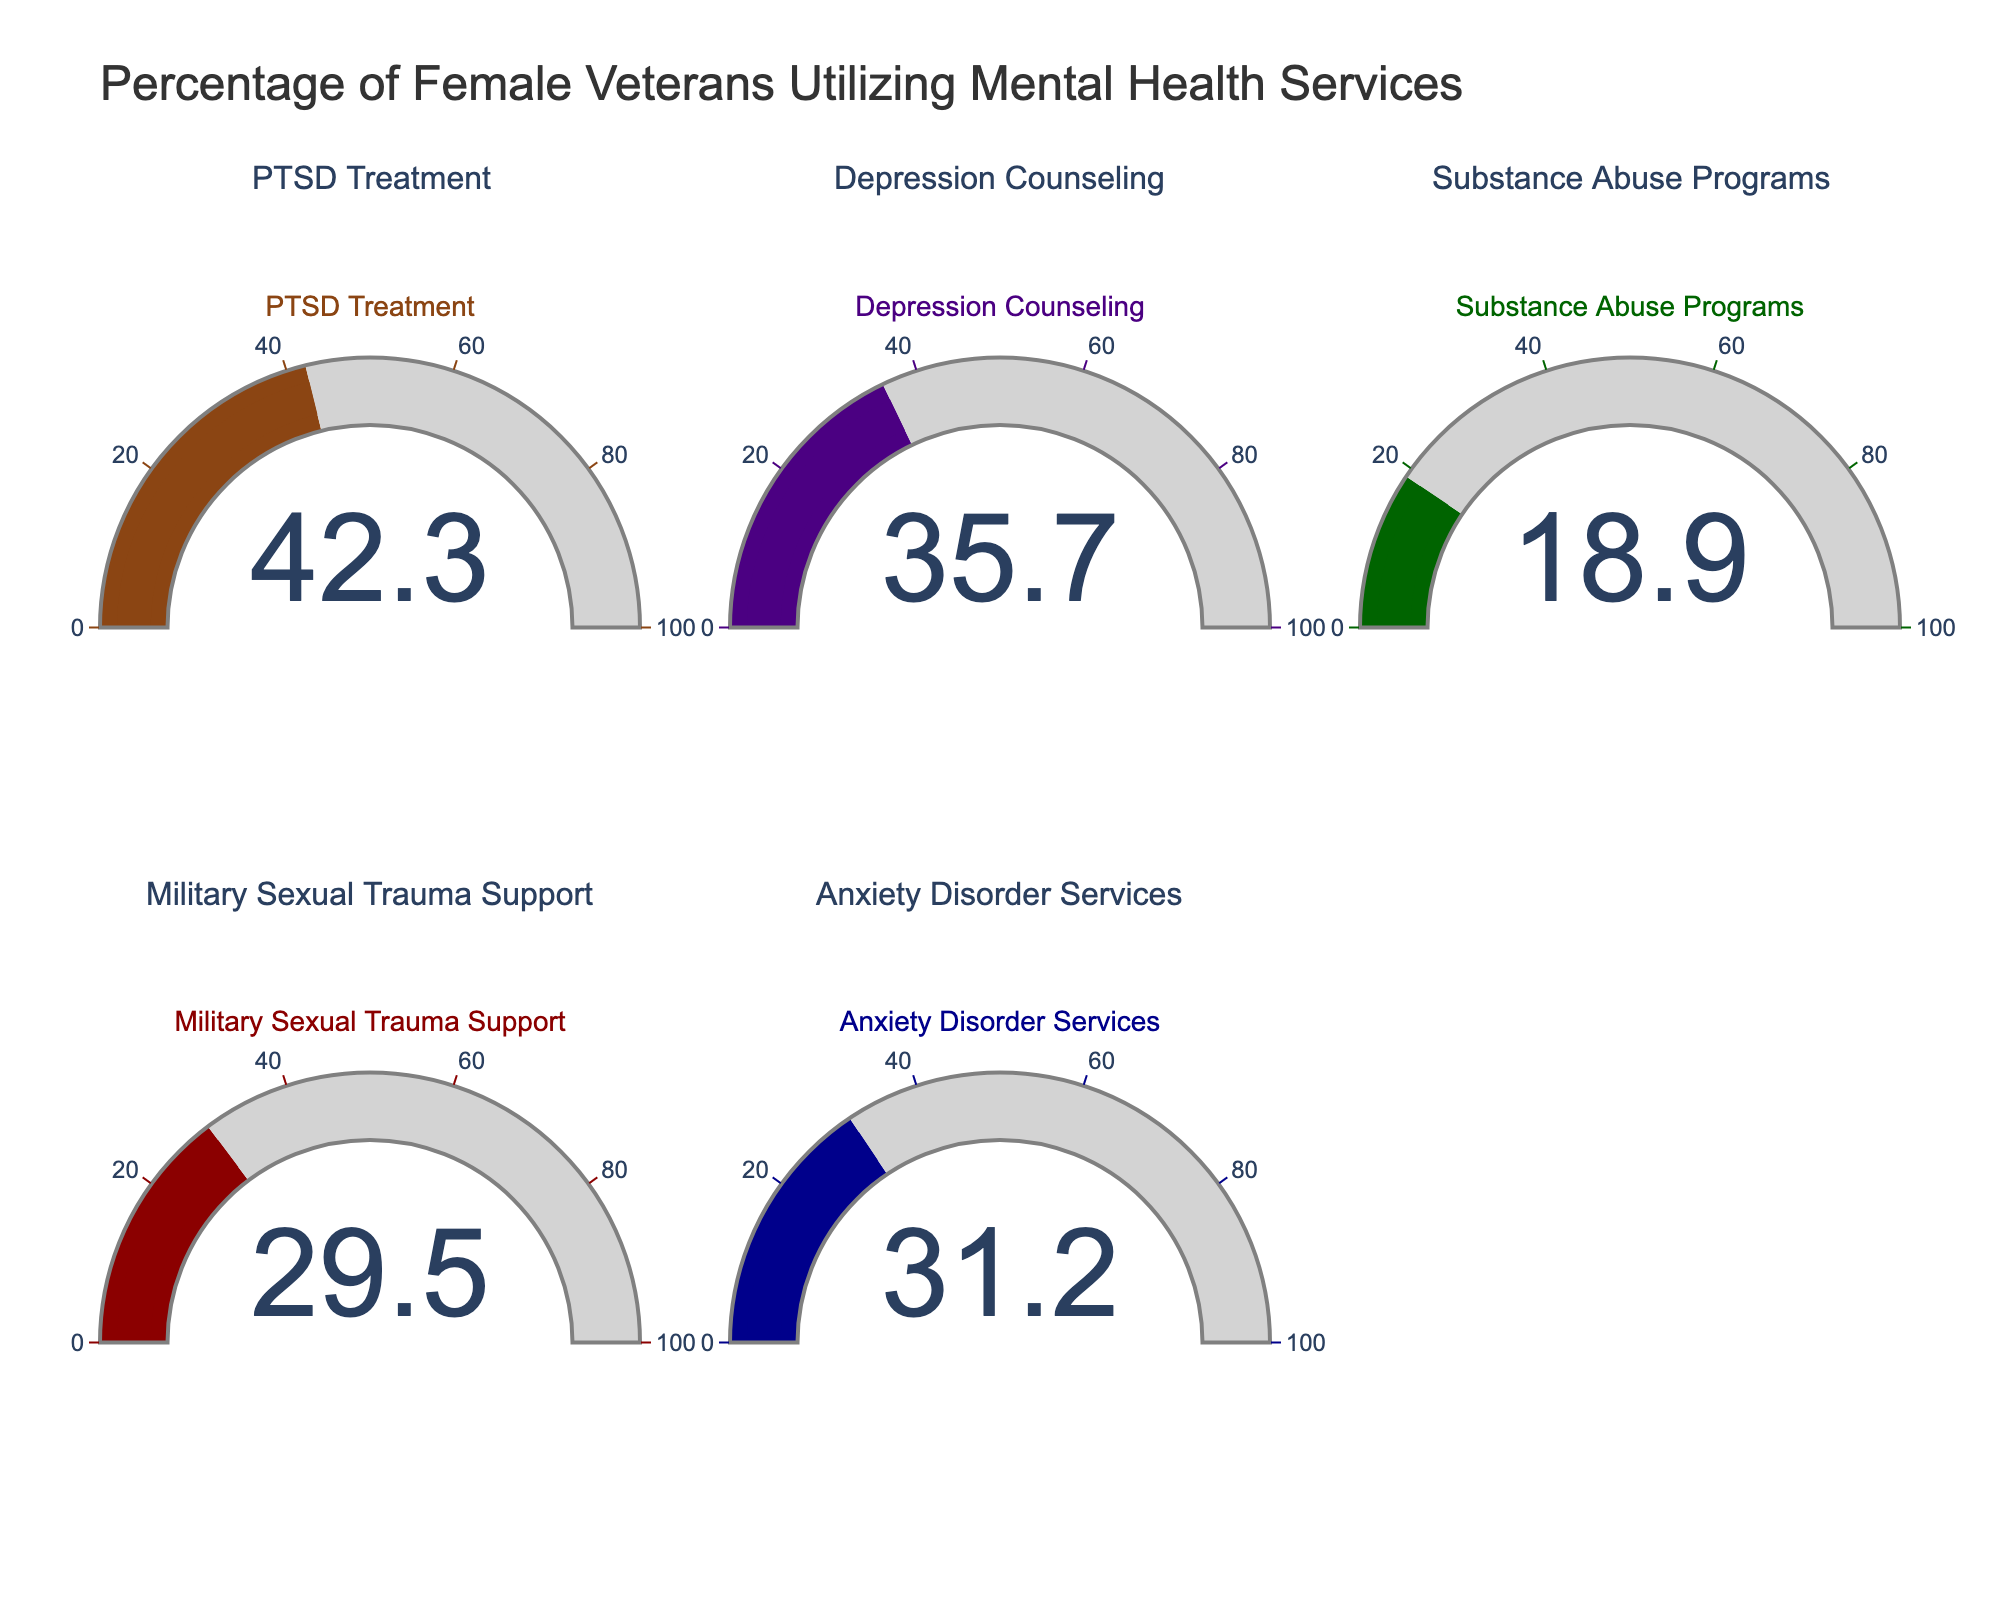What's the highest percentage of female veterans utilizing mental health services? The gauge for PTSD Treatment shows the highest value among all. To find the highest percentage, look for the largest value displayed on the gauges.
Answer: 42.3 Which service has the lowest utilization percentage among female veterans? To find the lowest utilization percentage, look at all the values and identify the smallest one. Substance Abuse Programs has the lowest value.
Answer: 18.9 What is the total percentage of female veterans utilizing Anxiety Disorder Services and Military Sexual Trauma Support services? Add the values for Anxiety Disorder Services (31.2) and Military Sexual Trauma Support (29.5). 31.2 + 29.5 = 60.7
Answer: 60.7 Which services have utilization rates greater than 30%? Scan through the values on the gauges and pick those that are greater than 30%. PTSD Treatment (42.3), Depression Counseling (35.7), Anxiety Disorder Services (31.2), and Military Sexual Trauma Support (29.5 but count this as it’s close to 30).
Answer: PTSD Treatment, Depression Counseling, Anxiety Disorder Services Is the utilization percentage for Depression Counseling higher or lower than that for Military Sexual Trauma Support? Compare the values for Depression Counseling (35.7) and Military Sexual Trauma Support (29.5). Since 35.7 is greater than 29.5, it is higher.
Answer: Higher What is the average percentage utilization of services? To find the average, sum all the percentages and divide by the number of services. (42.3 + 35.7 + 18.9 + 29.5 + 31.2) / 5 = 31.52
Answer: 31.52 Which services have values within the range of 20% to 40%? Check all the values and see which ones fall between 20 and 40. Depression Counseling (35.7), Military Sexual Trauma Support (29.5), and Anxiety Disorder Services (31.2) are in this range.
Answer: Depression Counseling, Military Sexual Trauma Support, Anxiety Disorder Services 